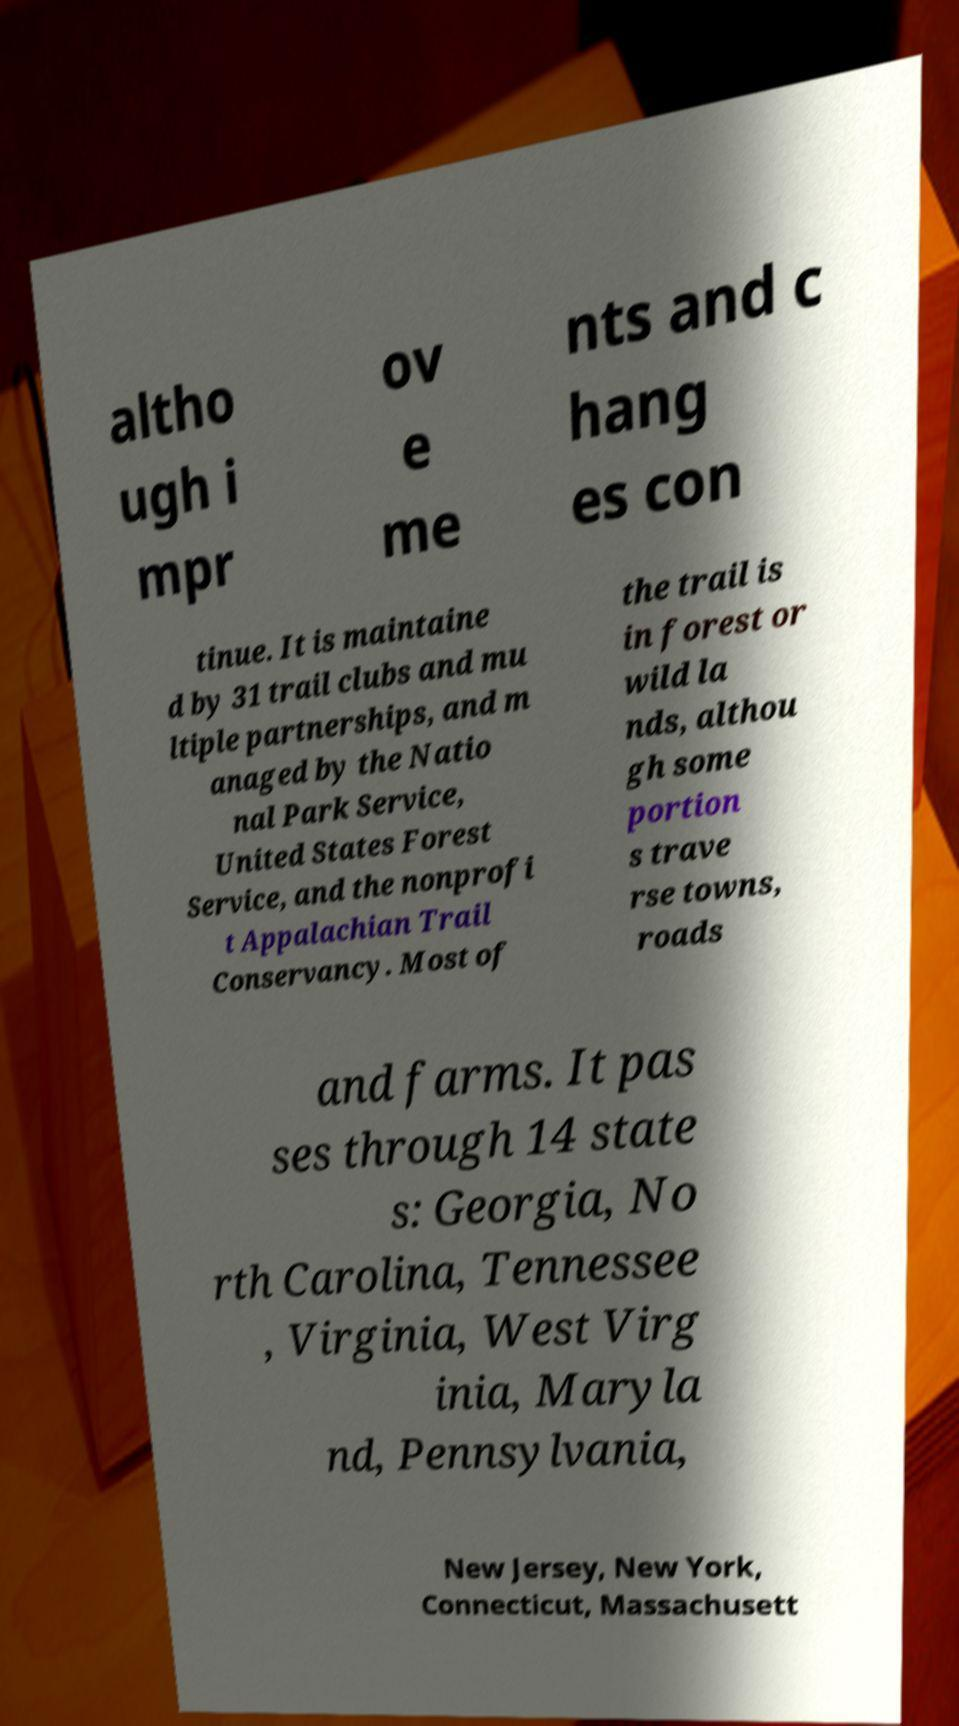For documentation purposes, I need the text within this image transcribed. Could you provide that? altho ugh i mpr ov e me nts and c hang es con tinue. It is maintaine d by 31 trail clubs and mu ltiple partnerships, and m anaged by the Natio nal Park Service, United States Forest Service, and the nonprofi t Appalachian Trail Conservancy. Most of the trail is in forest or wild la nds, althou gh some portion s trave rse towns, roads and farms. It pas ses through 14 state s: Georgia, No rth Carolina, Tennessee , Virginia, West Virg inia, Maryla nd, Pennsylvania, New Jersey, New York, Connecticut, Massachusett 